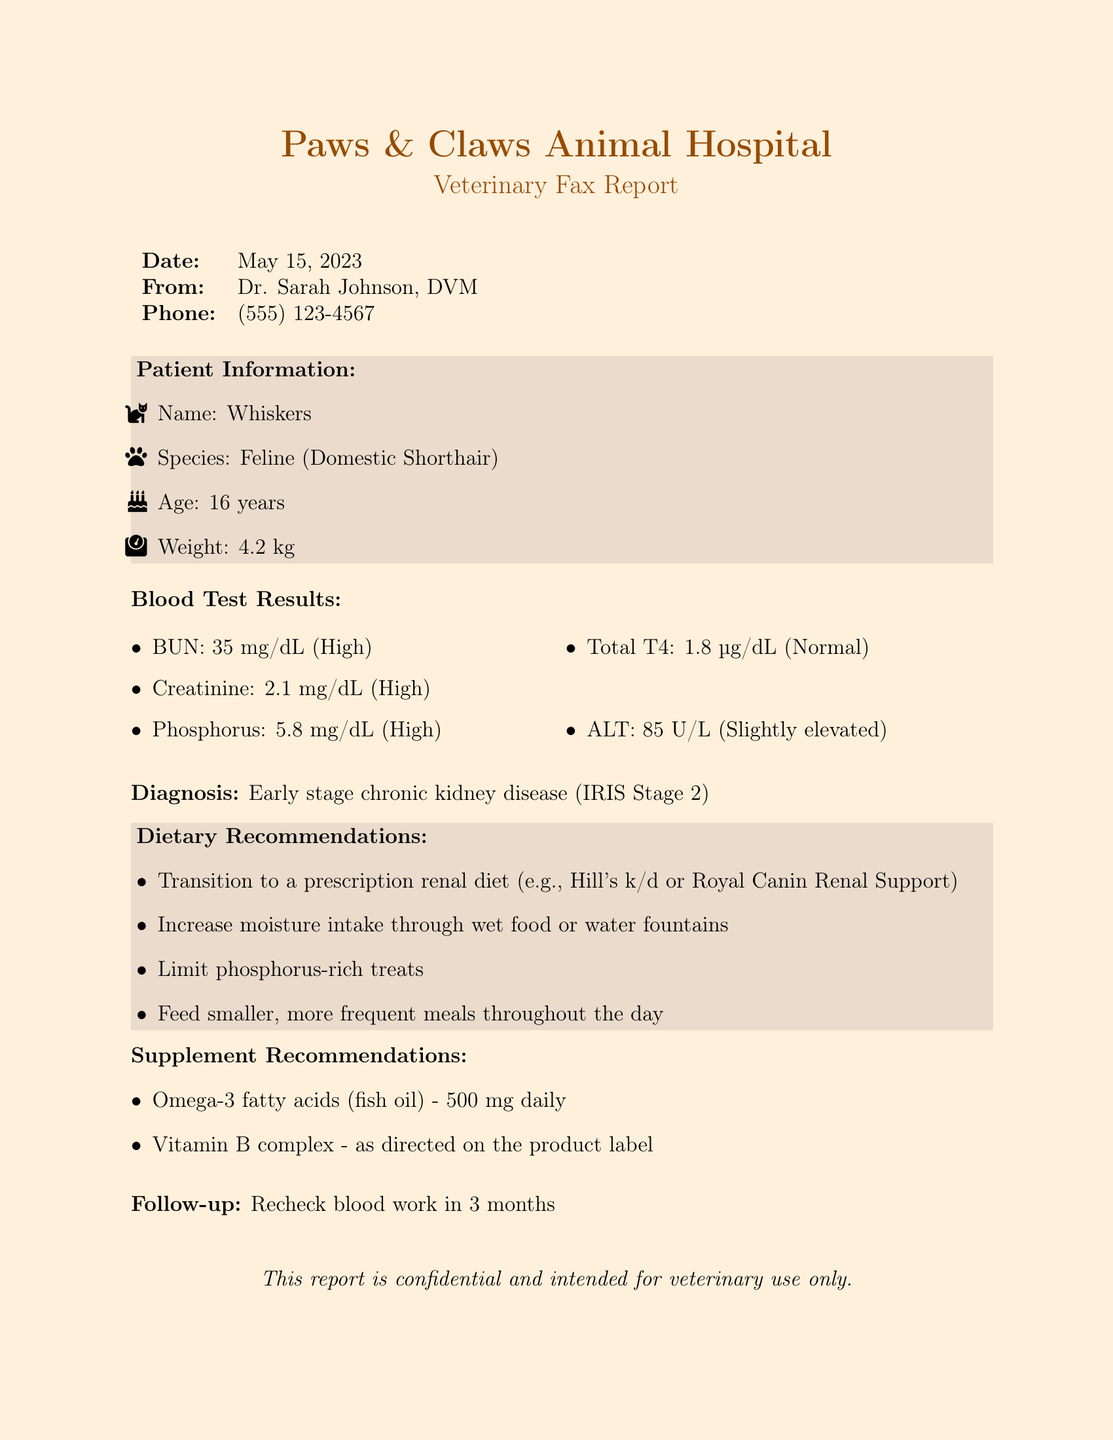What is the date of the report? The date of the report is found in the header section of the document.
Answer: May 15, 2023 Who is the veterinarian? The veterinarian's name is listed at the top of the document after "From:".
Answer: Dr. Sarah Johnson, DVM What is the age of the cat? The age of the cat is mentioned in the patient information section.
Answer: 16 years What is the diagnosis for Whiskers? The diagnosis is stated clearly in the document after the blood test results.
Answer: Early stage chronic kidney disease (IRIS Stage 2) What are the recommended dietary changes? The dietary recommendations are outlined in a specific section of the document.
Answer: Transition to a prescription renal diet What is the phosphorus level? The phosphorus level is included in the blood test results section.
Answer: 5.8 mg/dL (High) How often should follow-up blood work be done? The follow-up timing is found at the end of the report.
Answer: In 3 months What supplement is recommended for Whiskers? The supplement recommendations section lists some suggested supplements.
Answer: Omega-3 fatty acids (fish oil) What is Whiskers' weight? The weight is provided in the patient information section of the document.
Answer: 4.2 kg 